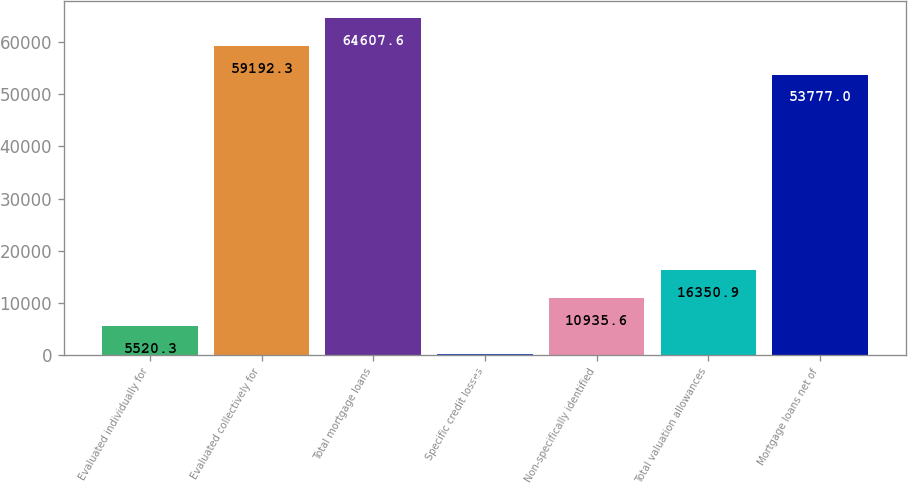Convert chart to OTSL. <chart><loc_0><loc_0><loc_500><loc_500><bar_chart><fcel>Evaluated individually for<fcel>Evaluated collectively for<fcel>Total mortgage loans<fcel>Specific credit losses<fcel>Non-specifically identified<fcel>Total valuation allowances<fcel>Mortgage loans net of<nl><fcel>5520.3<fcel>59192.3<fcel>64607.6<fcel>105<fcel>10935.6<fcel>16350.9<fcel>53777<nl></chart> 